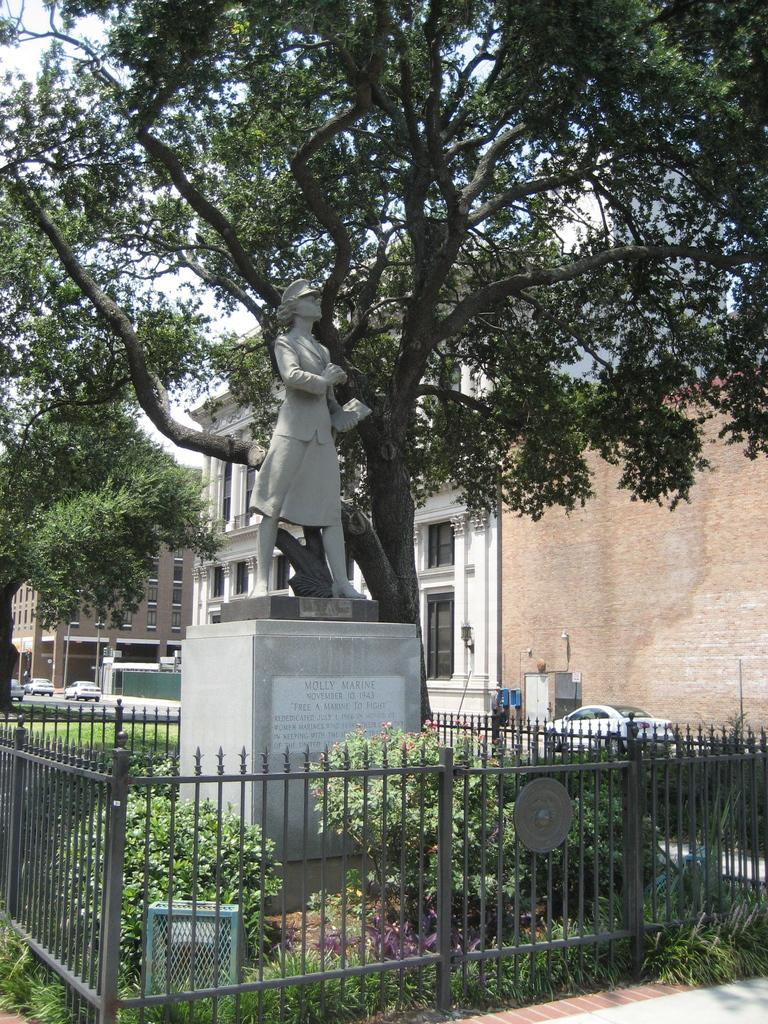Provide a one-sentence caption for the provided image. A statue of Molly Marine is erected in a small city square. 